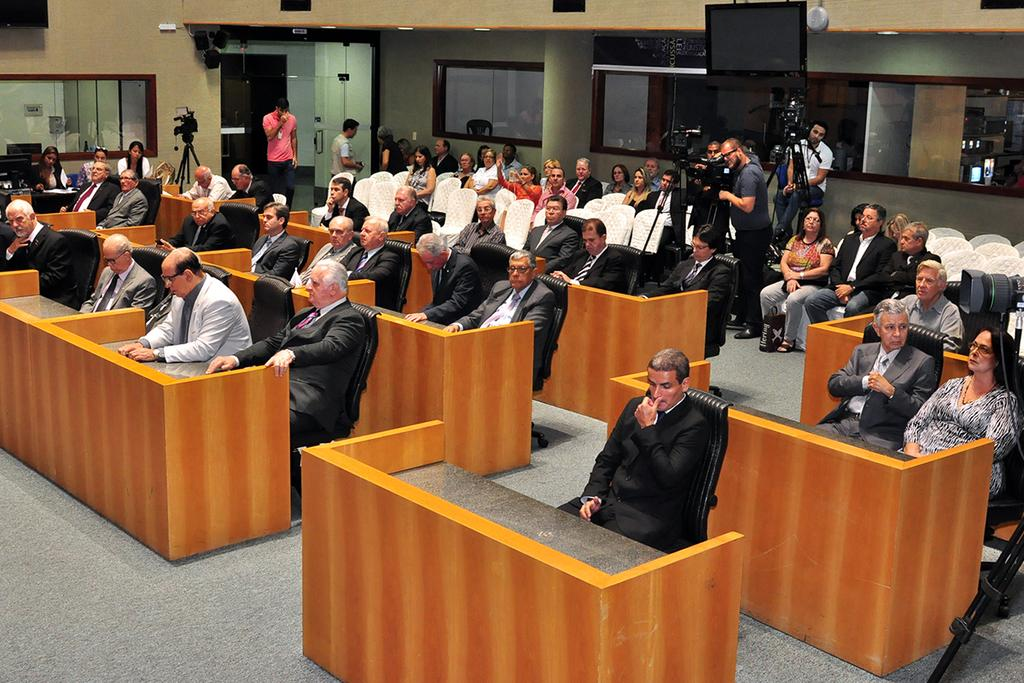What is at the bottom of the image? There is a floor at the bottom of the image. Who or what can be seen in the image? There are people in the image. What type of furniture is present in the image? There are chairs and desks in the image. What devices are visible in the image? There are cameras and a television in the image. What architectural features can be seen in the image? There are windows and a door in the image. What is on the roof in the image? There are lights on the roof in the image. What type of store can be seen in the image? There is no store present in the image. What season is it in the image? The provided facts do not mention any seasonal details, so it cannot be determined from the image. 